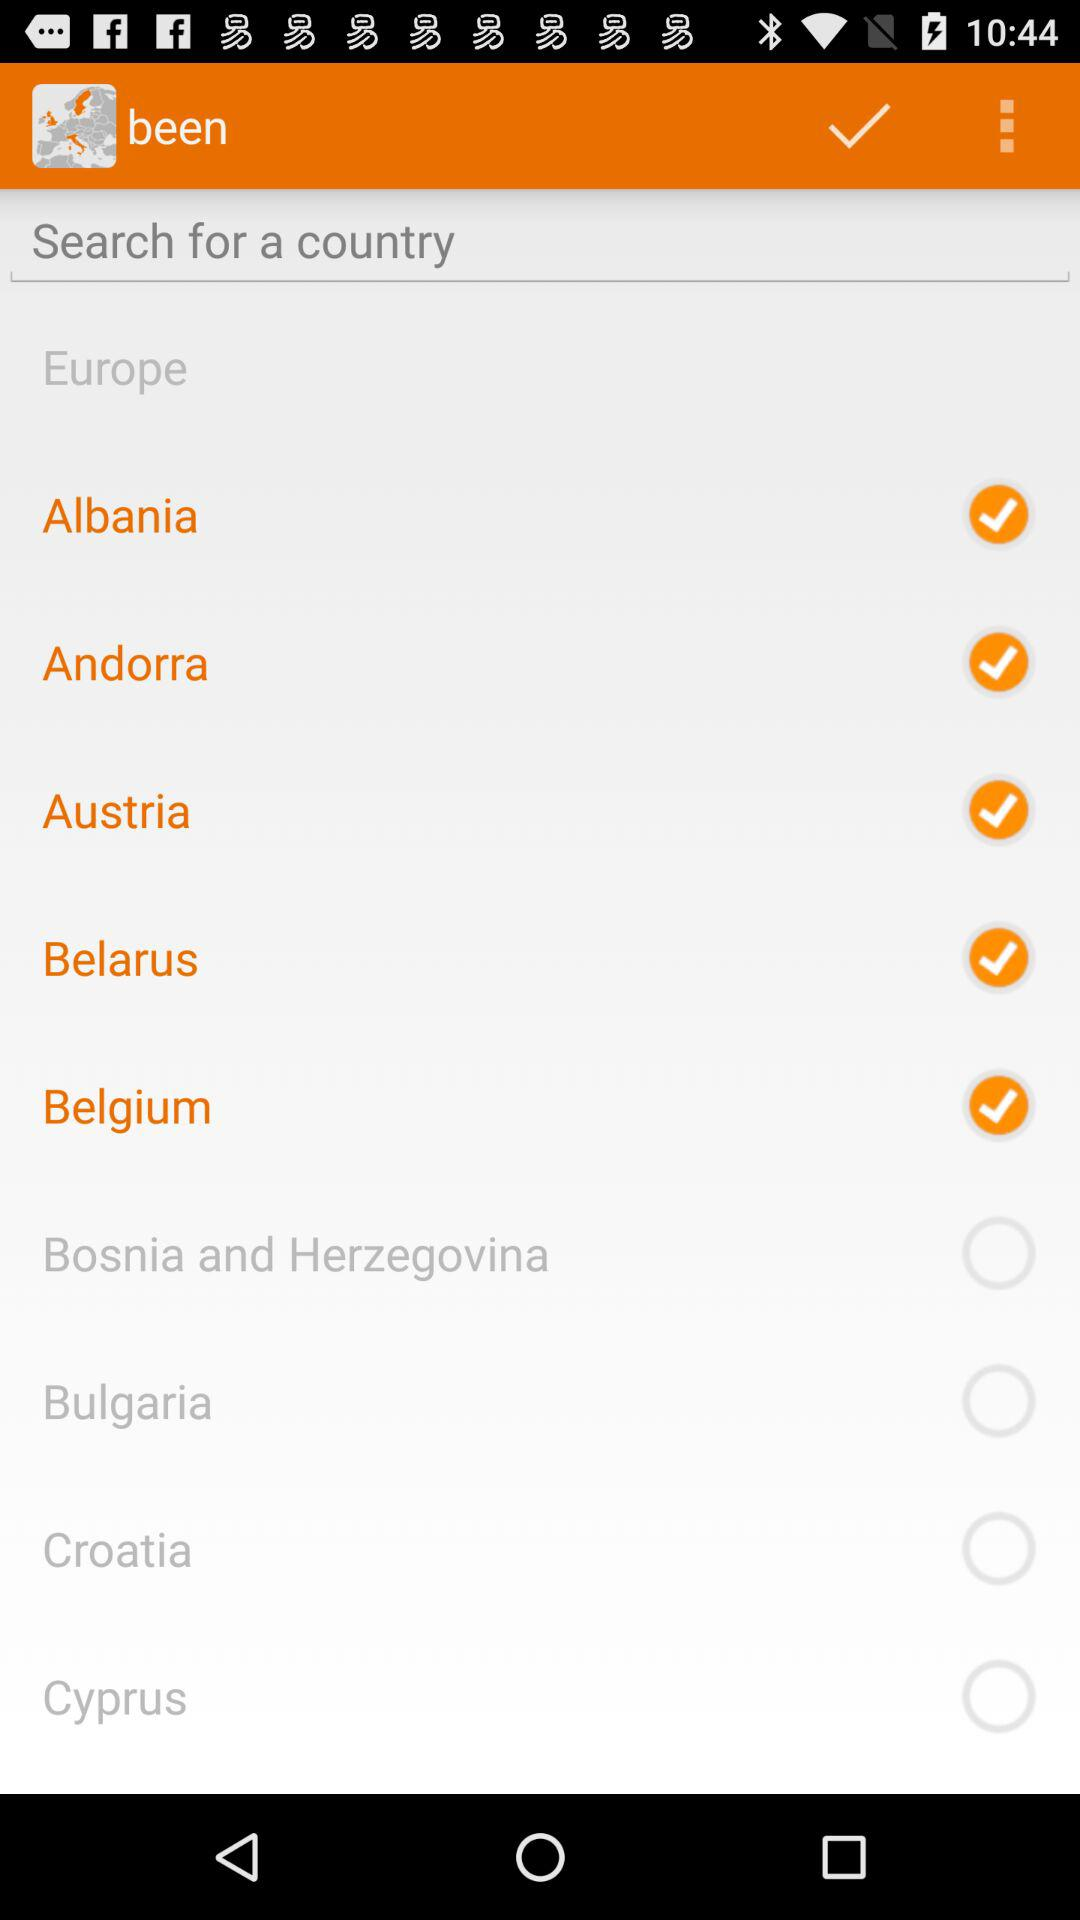Which country has been selected? The countries are "Albania", "Andorra", "Austria", "Belarus" and "Belgium". 